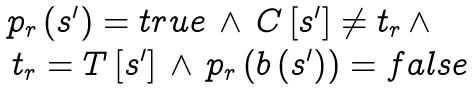Convert formula to latex. <formula><loc_0><loc_0><loc_500><loc_500>\begin{array} { l } p _ { r } \left ( s ^ { \prime } \right ) = t r u e \, \wedge \, C \left [ s ^ { \prime } \right ] \neq t _ { r } \, \wedge \\ \, t _ { r } = T \left [ s ^ { \prime } \right ] \, \wedge \, p _ { r } \left ( b \left ( s ^ { \prime } \right ) \right ) = f a l s e \end{array}</formula> 